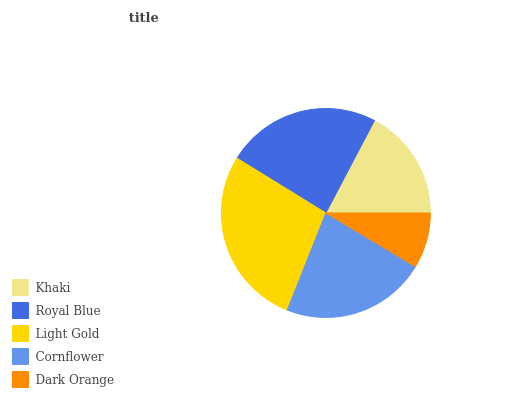Is Dark Orange the minimum?
Answer yes or no. Yes. Is Light Gold the maximum?
Answer yes or no. Yes. Is Royal Blue the minimum?
Answer yes or no. No. Is Royal Blue the maximum?
Answer yes or no. No. Is Royal Blue greater than Khaki?
Answer yes or no. Yes. Is Khaki less than Royal Blue?
Answer yes or no. Yes. Is Khaki greater than Royal Blue?
Answer yes or no. No. Is Royal Blue less than Khaki?
Answer yes or no. No. Is Cornflower the high median?
Answer yes or no. Yes. Is Cornflower the low median?
Answer yes or no. Yes. Is Light Gold the high median?
Answer yes or no. No. Is Light Gold the low median?
Answer yes or no. No. 